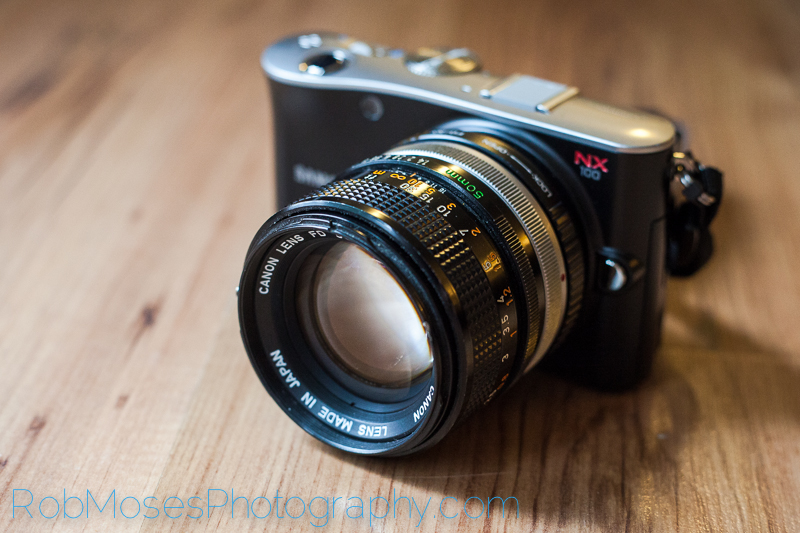Can you explain the benefits of using vintage lenses like the Canon FD on modern cameras? Using vintage lenses like the Canon FD on modern cameras can bring several benefits to photographers. Firstly, vintage lenses often produce unique optical characteristics, such as distinct bokeh, vignetting, or lens flare effects, which can add artistic flair to images. Secondly, they are typically well-built with quality materials, offering a tactile shooting experience with manual controls. Additionally, using vintage lenses can be more cost-effective compared to buying new, high-end lenses. Adaptable to various modern camera bodies via adapters, they allow photographers to explore a wider range of creative possibilities, blending the nostalgia and craftsmanship of classic optics with the technological advancements of current digital sensors. How does one ensure proper focus using a manual focus lens on a digital camera body? Ensuring proper focus with a manual focus lens on a digital camera body involves a few techniques to help achieve sharp images. First, use the camera's focus magnification feature, which enlarges the live view or EVF image, allowing for more precise manual focusing. Second, focus peaking can be activated on some digital cameras, which highlights the areas of the image that are in focus, making it easier to see where the sharpest focus is. Third, practice and familiarity with the lens will improve focusing speeds and accuracy. Lastly, using a tripod for stability, especially in critical focusing situations, can minimize the risk of camera shake and help maintain focus on the desired subject. What would be a scenario where combining a vintage lens with a modern camera could be particularly advantageous? A scenario where combining a vintage lens with a modern camera could be particularly advantageous is during portrait photography. Vintage lenses often have a softer, more flattering rendering of skin tones and can create beautiful, creamy bokeh due to their classic optical designs. This characteristic can produce an aesthetically pleasing and timeless quality in portraits, enhancing the artistic appeal of the images. Additionally, using a vintage lens can make the photos stand out by giving them a unique look that differs from the sharper, more clinical results of contemporary lenses. Imagine an extremely imaginative scenario where this vintage-modern lens combination could be magical. Imagine being a time-traveling photographer who has just stepped out of a portal into a parallel universe where every photograph taken tells an enchanting story. In this reality, your camera with a Canon FD lens possesses the ability to capture not just images but moments of time itself. Each snapshot holds the essence of a thousand untold narratives, and as the shutter clicks, the world around you momentarily freezes, allowing you to peek into the past and future intertwined in mesmerizing harmony. The vintage lens, with its legacy of decades past, imbues each image with a magical patina, weaving a visual tapestry that dances between epochs. This unique fusion of old and new technology transforms every photograph into a portal of wonder, inviting viewers to experience the timeless stories whispered through each captured scene. 